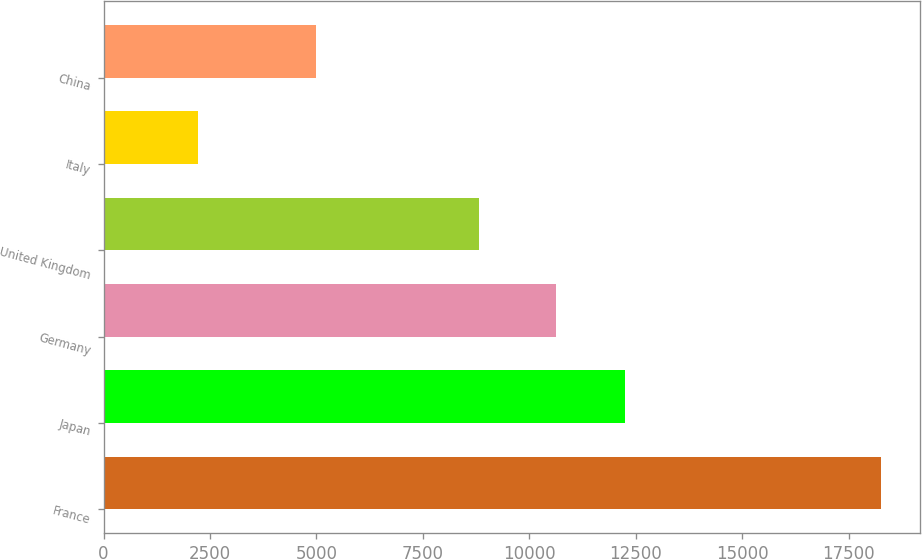Convert chart to OTSL. <chart><loc_0><loc_0><loc_500><loc_500><bar_chart><fcel>France<fcel>Japan<fcel>Germany<fcel>United Kingdom<fcel>Italy<fcel>China<nl><fcel>18261<fcel>12233.6<fcel>10629<fcel>8821<fcel>2215<fcel>4984<nl></chart> 